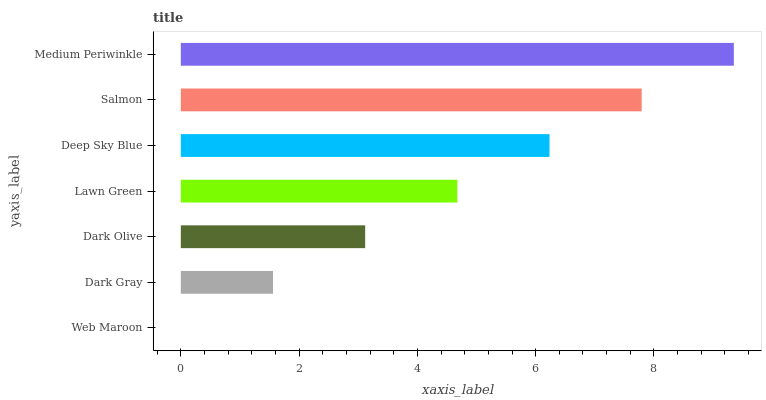Is Web Maroon the minimum?
Answer yes or no. Yes. Is Medium Periwinkle the maximum?
Answer yes or no. Yes. Is Dark Gray the minimum?
Answer yes or no. No. Is Dark Gray the maximum?
Answer yes or no. No. Is Dark Gray greater than Web Maroon?
Answer yes or no. Yes. Is Web Maroon less than Dark Gray?
Answer yes or no. Yes. Is Web Maroon greater than Dark Gray?
Answer yes or no. No. Is Dark Gray less than Web Maroon?
Answer yes or no. No. Is Lawn Green the high median?
Answer yes or no. Yes. Is Lawn Green the low median?
Answer yes or no. Yes. Is Medium Periwinkle the high median?
Answer yes or no. No. Is Web Maroon the low median?
Answer yes or no. No. 